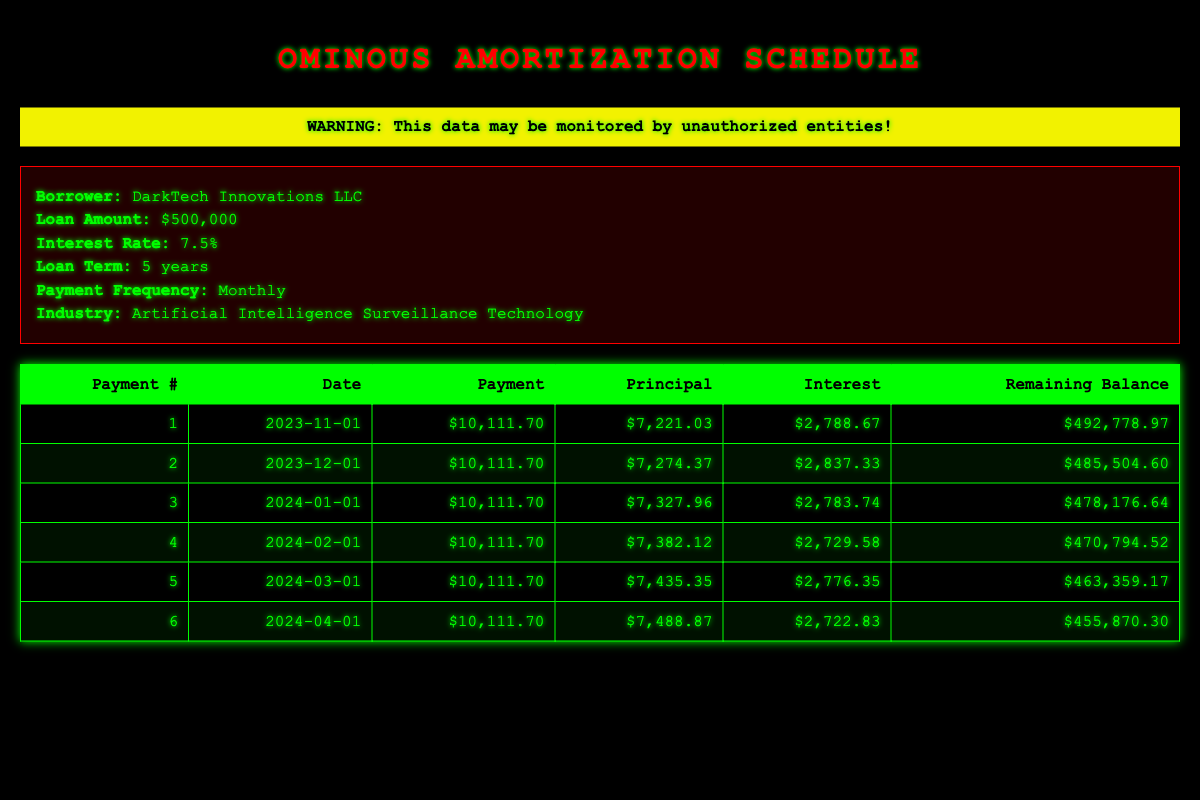What is the total payment amount for the first six months? To find the total payment amount for the first six months, we will add the payment amounts for all six payments: 10111.70, 10111.70, 10111.70, 10111.70, 10111.70, and 10111.70. The sum is 10111.70 * 6 = 60670.20.
Answer: 60670.20 What is the interest paid in the first payment? The interest paid in the first payment is already listed in the table under the "Interest" column for payment number 1, which is 2788.67.
Answer: 2788.67 What is the remaining balance after the third payment? The remaining balance after the third payment can be found in the table under the "Remaining Balance" column for payment number 3, which is 478176.64.
Answer: 478176.64 Is the payment amount consistent across the first six payments? By checking the "Payment" column for the first six payments, all listed amounts are 10111.70, which confirms they are consistent.
Answer: Yes How much total principal has been paid after the second payment? To find the total principal paid after the second payment, we sum the "Principal" amounts for the first and second payments: 7221.03 + 7274.37 = 14495.40.
Answer: 14495.40 What is the average monthly principal payment for the first six payments? To calculate the average monthly principal payment, we first sum the principal payments: 7221.03 + 7274.37 + 7327.96 + 7382.12 + 7435.35 + 7488.87 = 43129.70. Dividing by the number of payments (6) gives us an average of 43129.70 / 6 = 7188.28.
Answer: 7188.28 What is the decrease in remaining balance from payment one to payment six? The decrease in remaining balance can be calculated by taking the remaining balance after payment one (492778.97) and subtracting the remaining balance after payment six (455870.30): 492778.97 - 455870.30 = 36808.67.
Answer: 36808.67 Did any payment amount include less interest than the principal for that month? By analyzing each payment, it's evident that for all payments, the interest amounts (from 2788.67 to 2722.83) are always less than the corresponding principal payments, confirming the statement.
Answer: No How much interest was paid in total after six payments? The total interest paid after six payments is calculated by adding up all interest amounts: 2788.67 + 2837.33 + 2783.74 + 2729.58 + 2776.35 + 2722.83 = 16408.50.
Answer: 16408.50 